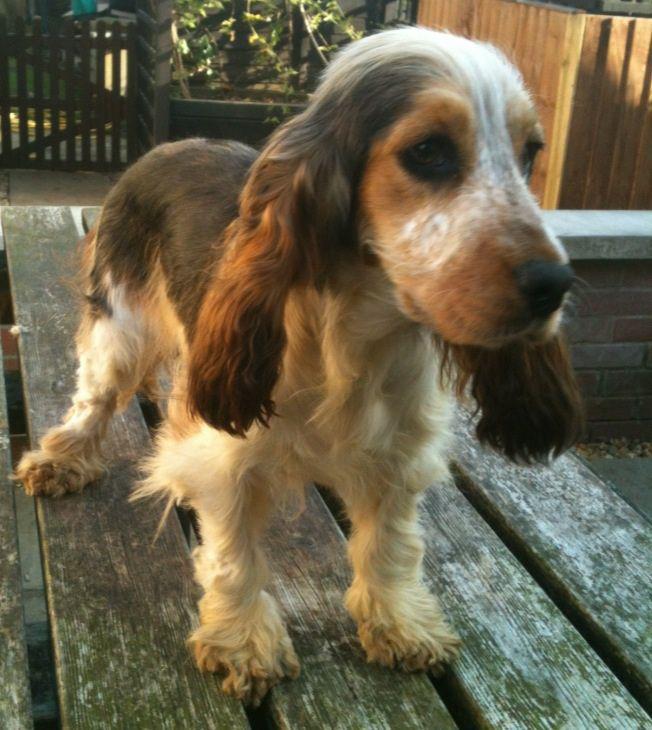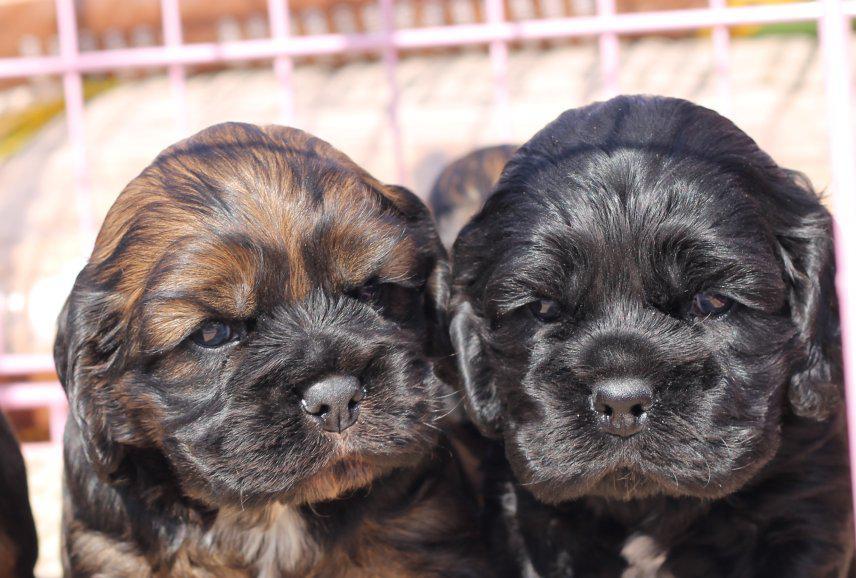The first image is the image on the left, the second image is the image on the right. Analyze the images presented: Is the assertion "A human is holding a dog in one of the images." valid? Answer yes or no. No. The first image is the image on the left, the second image is the image on the right. Given the left and right images, does the statement "An image contains two dogs side by side." hold true? Answer yes or no. Yes. 